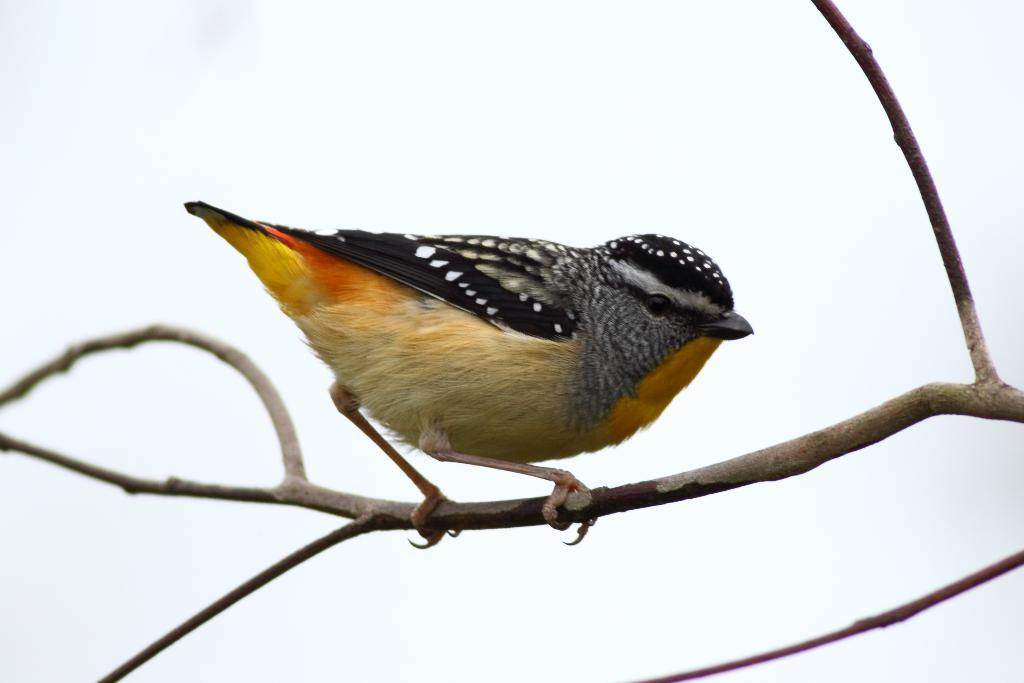What type of animal is in the image? There is a bird in the image. Where is the bird located? The bird is on the branch of a tree. What can be seen in the background of the image? The sky is visible in the image. What type of music is the bird playing in the image? There is no music present in the image, as it features a bird on a tree branch with a visible sky. 